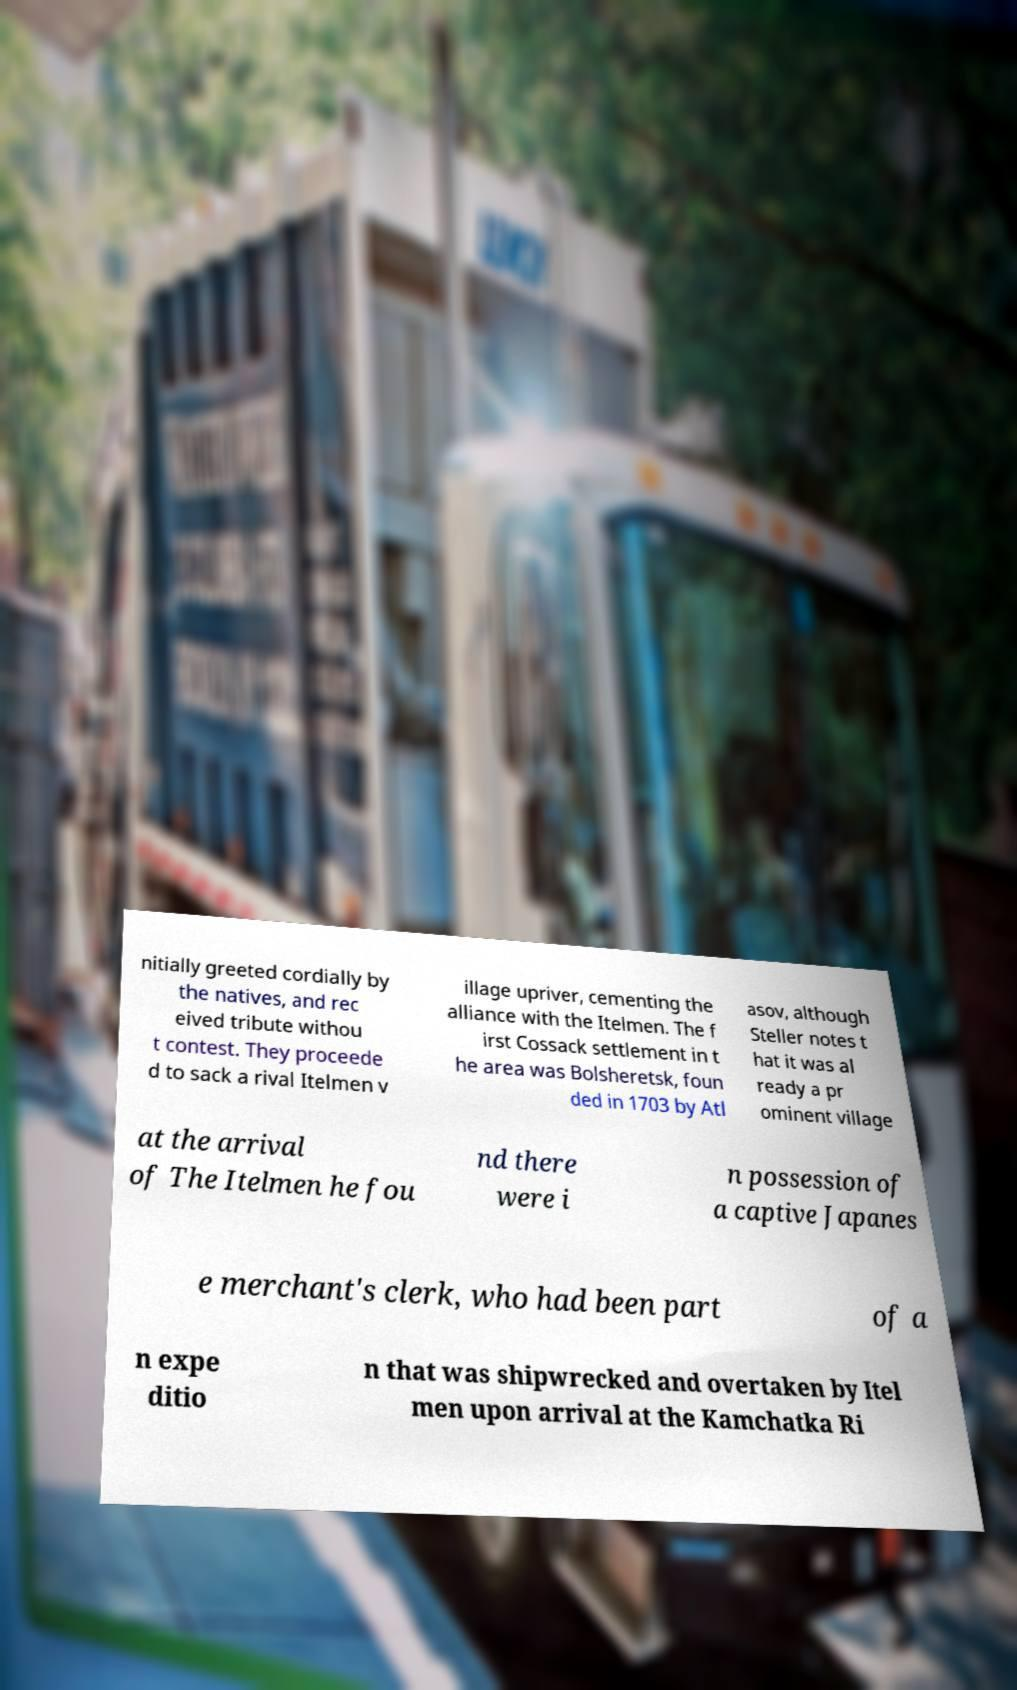There's text embedded in this image that I need extracted. Can you transcribe it verbatim? nitially greeted cordially by the natives, and rec eived tribute withou t contest. They proceede d to sack a rival Itelmen v illage upriver, cementing the alliance with the Itelmen. The f irst Cossack settlement in t he area was Bolsheretsk, foun ded in 1703 by Atl asov, although Steller notes t hat it was al ready a pr ominent village at the arrival of The Itelmen he fou nd there were i n possession of a captive Japanes e merchant's clerk, who had been part of a n expe ditio n that was shipwrecked and overtaken by Itel men upon arrival at the Kamchatka Ri 